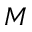Convert formula to latex. <formula><loc_0><loc_0><loc_500><loc_500>M</formula> 